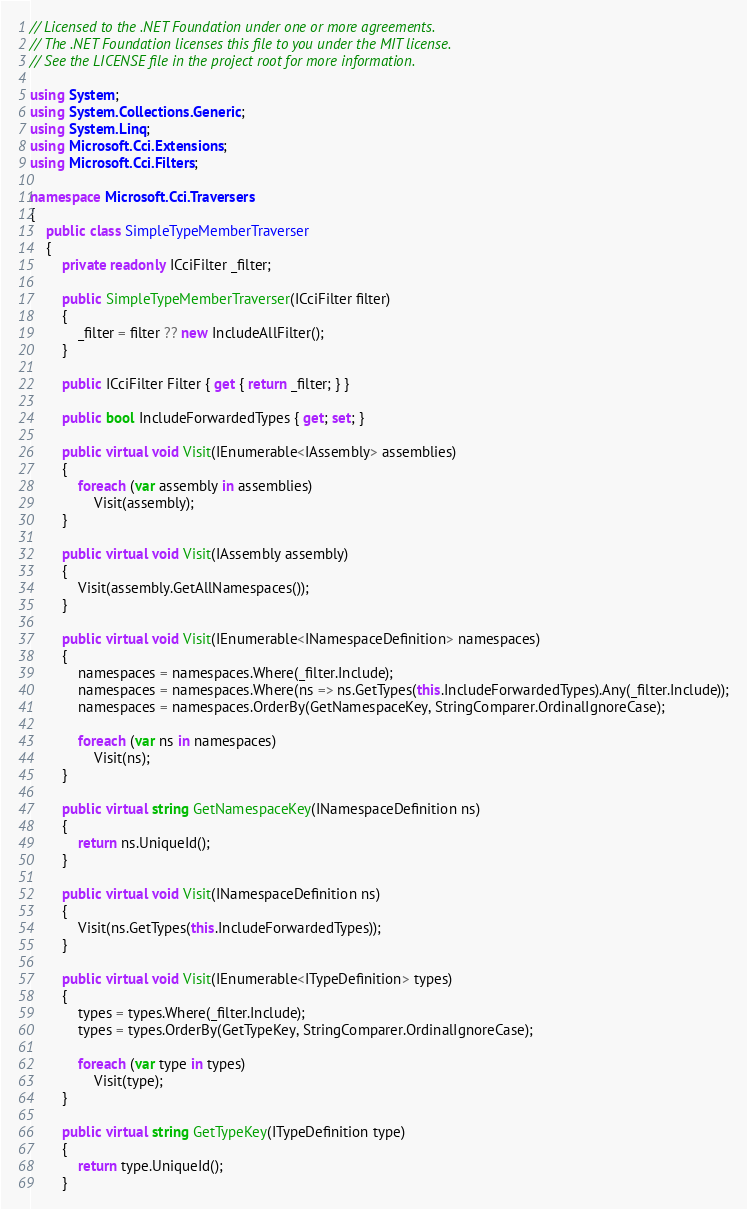<code> <loc_0><loc_0><loc_500><loc_500><_C#_>// Licensed to the .NET Foundation under one or more agreements.
// The .NET Foundation licenses this file to you under the MIT license.
// See the LICENSE file in the project root for more information.

using System;
using System.Collections.Generic;
using System.Linq;
using Microsoft.Cci.Extensions;
using Microsoft.Cci.Filters;

namespace Microsoft.Cci.Traversers
{
    public class SimpleTypeMemberTraverser
    {
        private readonly ICciFilter _filter;

        public SimpleTypeMemberTraverser(ICciFilter filter)
        {
            _filter = filter ?? new IncludeAllFilter();
        }

        public ICciFilter Filter { get { return _filter; } }

        public bool IncludeForwardedTypes { get; set; }

        public virtual void Visit(IEnumerable<IAssembly> assemblies)
        {
            foreach (var assembly in assemblies)
                Visit(assembly);
        }

        public virtual void Visit(IAssembly assembly)
        {
            Visit(assembly.GetAllNamespaces());
        }

        public virtual void Visit(IEnumerable<INamespaceDefinition> namespaces)
        {
            namespaces = namespaces.Where(_filter.Include);
            namespaces = namespaces.Where(ns => ns.GetTypes(this.IncludeForwardedTypes).Any(_filter.Include));
            namespaces = namespaces.OrderBy(GetNamespaceKey, StringComparer.OrdinalIgnoreCase);

            foreach (var ns in namespaces)
                Visit(ns);
        }

        public virtual string GetNamespaceKey(INamespaceDefinition ns)
        {
            return ns.UniqueId();
        }

        public virtual void Visit(INamespaceDefinition ns)
        {
            Visit(ns.GetTypes(this.IncludeForwardedTypes));
        }

        public virtual void Visit(IEnumerable<ITypeDefinition> types)
        {
            types = types.Where(_filter.Include);
            types = types.OrderBy(GetTypeKey, StringComparer.OrdinalIgnoreCase);

            foreach (var type in types)
                Visit(type);
        }

        public virtual string GetTypeKey(ITypeDefinition type)
        {
            return type.UniqueId();
        }
</code> 